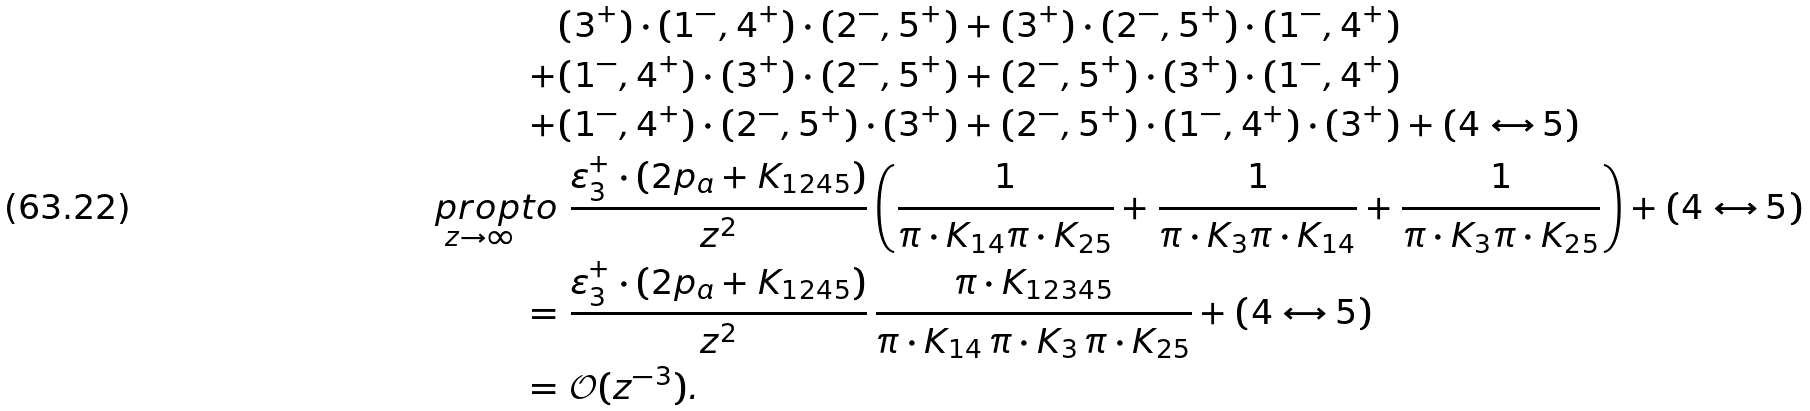Convert formula to latex. <formula><loc_0><loc_0><loc_500><loc_500>& ( 3 ^ { + } ) \cdot ( 1 ^ { - } , 4 ^ { + } ) \cdot ( 2 ^ { - } , 5 ^ { + } ) + ( 3 ^ { + } ) \cdot ( 2 ^ { - } , 5 ^ { + } ) \cdot ( 1 ^ { - } , 4 ^ { + } ) \\ + & ( 1 ^ { - } , 4 ^ { + } ) \cdot ( 3 ^ { + } ) \cdot ( 2 ^ { - } , 5 ^ { + } ) + ( 2 ^ { - } , 5 ^ { + } ) \cdot ( 3 ^ { + } ) \cdot ( 1 ^ { - } , 4 ^ { + } ) \\ + & ( 1 ^ { - } , 4 ^ { + } ) \cdot ( 2 ^ { - } , 5 ^ { + } ) \cdot ( 3 ^ { + } ) + ( 2 ^ { - } , 5 ^ { + } ) \cdot ( 1 ^ { - } , 4 ^ { + } ) \cdot ( 3 ^ { + } ) + ( 4 \leftrightarrow 5 ) \\ \underset { z \to \infty } { \quad p r o p t o } & \ \frac { \varepsilon _ { 3 } ^ { + } \cdot ( 2 p _ { a } + K _ { 1 2 4 5 } ) } { z ^ { 2 } } \left ( \frac { 1 } { \pi \cdot K _ { 1 4 } \pi \cdot K _ { 2 5 } } + \frac { 1 } { \pi \cdot K _ { 3 } \pi \cdot K _ { 1 4 } } + \frac { 1 } { \pi \cdot K _ { 3 } \pi \cdot K _ { 2 5 } } \right ) + ( 4 \leftrightarrow 5 ) \\ = & \ \frac { \varepsilon _ { 3 } ^ { + } \cdot ( 2 p _ { a } + K _ { 1 2 4 5 } ) } { z ^ { 2 } } \, \frac { \pi \cdot K _ { 1 2 3 4 5 } } { \pi \cdot K _ { 1 4 } \, \pi \cdot K _ { 3 } \, \pi \cdot K _ { 2 5 } } + ( 4 \leftrightarrow 5 ) \\ = & \ \mathcal { O } ( z ^ { - 3 } ) .</formula> 